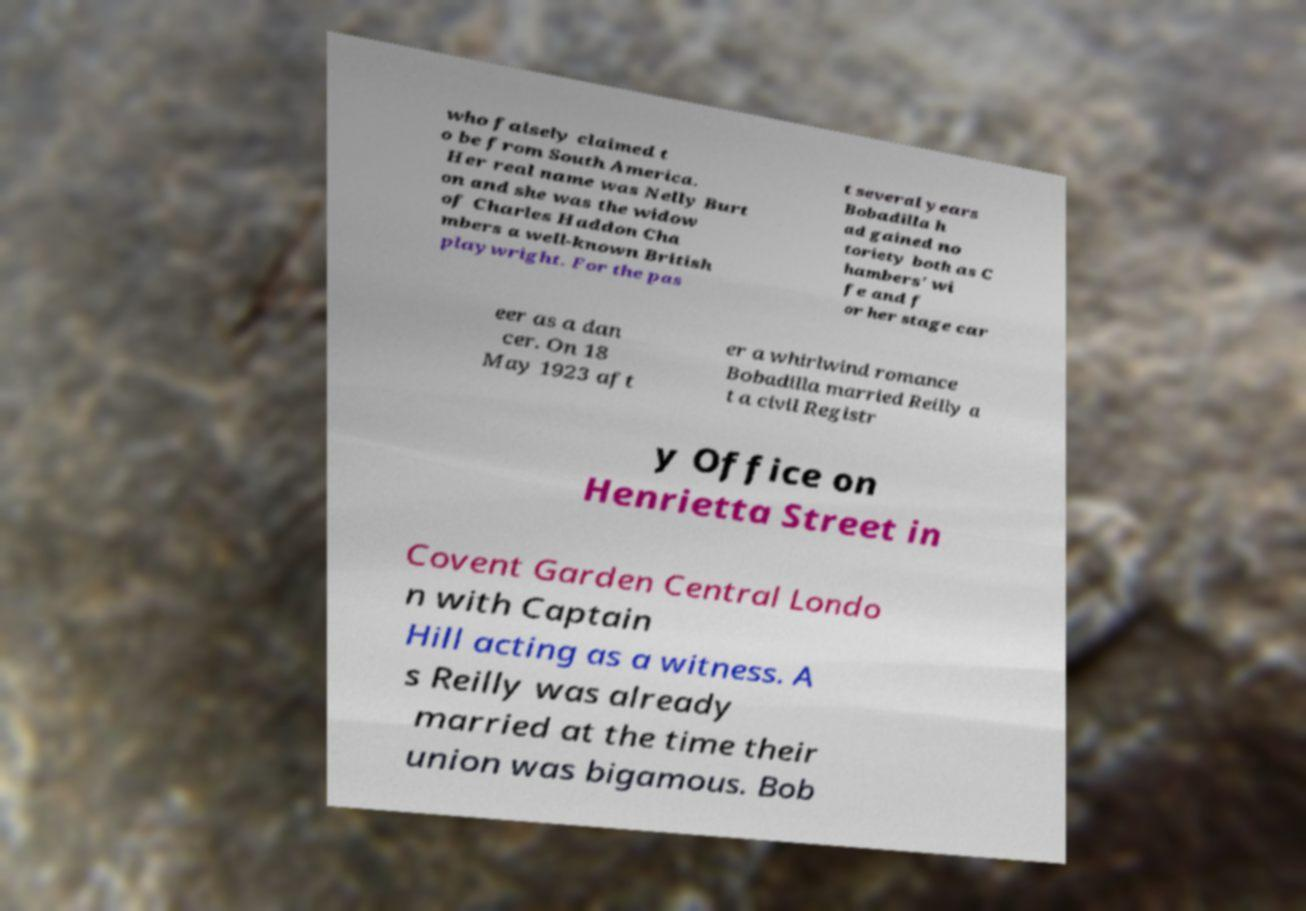Could you assist in decoding the text presented in this image and type it out clearly? who falsely claimed t o be from South America. Her real name was Nelly Burt on and she was the widow of Charles Haddon Cha mbers a well-known British playwright. For the pas t several years Bobadilla h ad gained no toriety both as C hambers' wi fe and f or her stage car eer as a dan cer. On 18 May 1923 aft er a whirlwind romance Bobadilla married Reilly a t a civil Registr y Office on Henrietta Street in Covent Garden Central Londo n with Captain Hill acting as a witness. A s Reilly was already married at the time their union was bigamous. Bob 